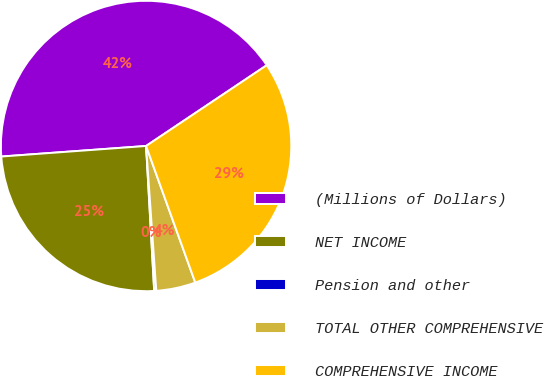<chart> <loc_0><loc_0><loc_500><loc_500><pie_chart><fcel>(Millions of Dollars)<fcel>NET INCOME<fcel>Pension and other<fcel>TOTAL OTHER COMPREHENSIVE<fcel>COMPREHENSIVE INCOME<nl><fcel>41.77%<fcel>24.73%<fcel>0.23%<fcel>4.38%<fcel>28.89%<nl></chart> 